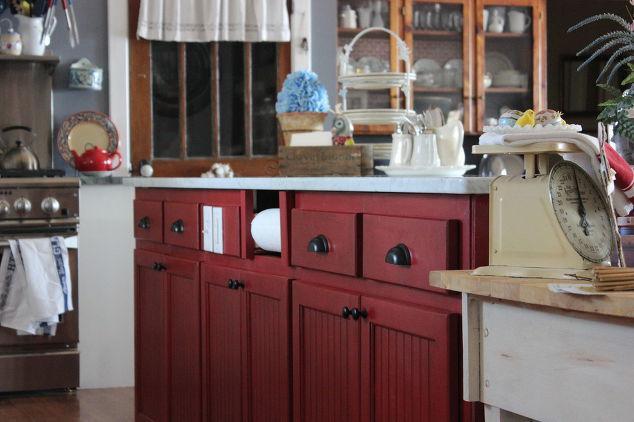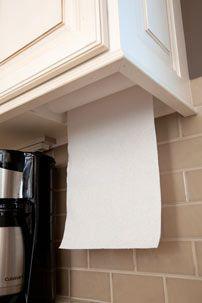The first image is the image on the left, the second image is the image on the right. Given the left and right images, does the statement "One of the paper towel rolls is tucked under the upper cabinet." hold true? Answer yes or no. Yes. 